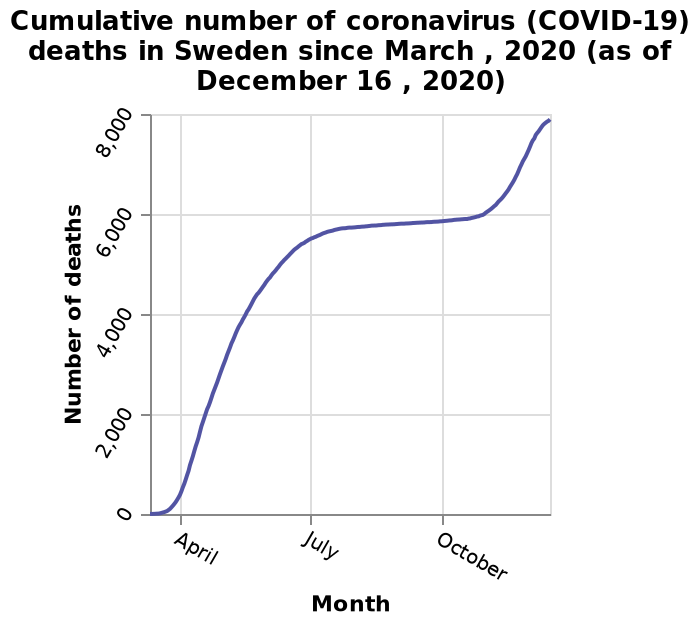<image>
What happened to the number of Covid deaths in Sweden from March to July?  The number of Covid deaths in Sweden rose considerably from March to July. What is the highest number of deaths shown on the line plot? The line plot does not provide the exact highest number of deaths, but it indicates that the y-axis scale goes up to 8,000 deaths. 